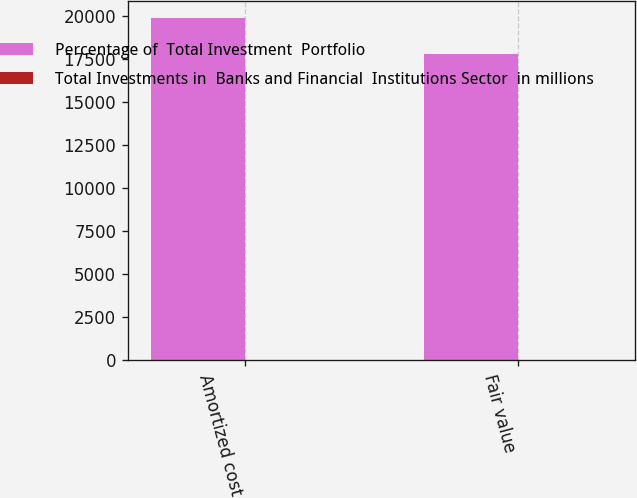Convert chart to OTSL. <chart><loc_0><loc_0><loc_500><loc_500><stacked_bar_chart><ecel><fcel>Amortized cost<fcel>Fair value<nl><fcel>Percentage of  Total Investment  Portfolio<fcel>19868<fcel>17793<nl><fcel>Total Investments in  Banks and Financial  Institutions Sector  in millions<fcel>28<fcel>27<nl></chart> 